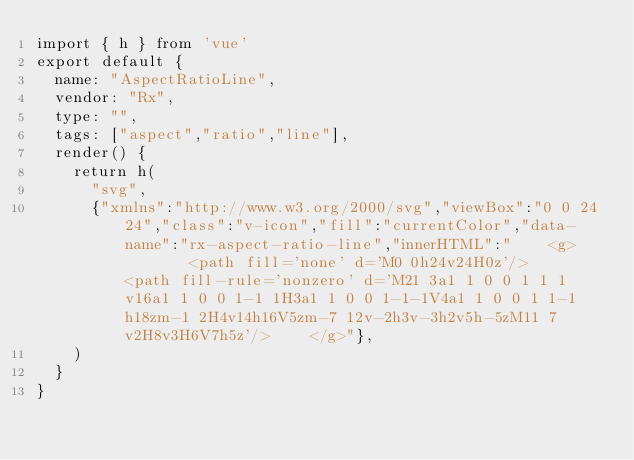<code> <loc_0><loc_0><loc_500><loc_500><_JavaScript_>import { h } from 'vue'
export default {
  name: "AspectRatioLine",
  vendor: "Rx",
  type: "",
  tags: ["aspect","ratio","line"],
  render() {
    return h(
      "svg",
      {"xmlns":"http://www.w3.org/2000/svg","viewBox":"0 0 24 24","class":"v-icon","fill":"currentColor","data-name":"rx-aspect-ratio-line","innerHTML":"    <g>        <path fill='none' d='M0 0h24v24H0z'/>        <path fill-rule='nonzero' d='M21 3a1 1 0 0 1 1 1v16a1 1 0 0 1-1 1H3a1 1 0 0 1-1-1V4a1 1 0 0 1 1-1h18zm-1 2H4v14h16V5zm-7 12v-2h3v-3h2v5h-5zM11 7v2H8v3H6V7h5z'/>    </g>"},
    )
  }
}</code> 